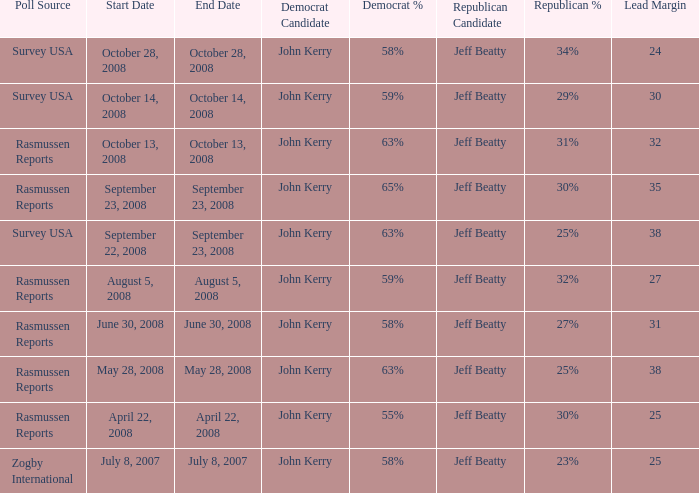Would you be able to parse every entry in this table? {'header': ['Poll Source', 'Start Date', 'End Date', 'Democrat Candidate', 'Democrat %', 'Republican Candidate', 'Republican %', 'Lead Margin'], 'rows': [['Survey USA', 'October 28, 2008', 'October 28, 2008', 'John Kerry', '58%', 'Jeff Beatty', '34%', '24'], ['Survey USA', 'October 14, 2008', 'October 14, 2008', 'John Kerry', '59%', 'Jeff Beatty', '29%', '30'], ['Rasmussen Reports', 'October 13, 2008', 'October 13, 2008', 'John Kerry', '63%', 'Jeff Beatty', '31%', '32'], ['Rasmussen Reports', 'September 23, 2008', 'September 23, 2008', 'John Kerry', '65%', 'Jeff Beatty', '30%', '35'], ['Survey USA', 'September 22, 2008', 'September 23, 2008', 'John Kerry', '63%', 'Jeff Beatty', '25%', '38'], ['Rasmussen Reports', 'August 5, 2008', 'August 5, 2008', 'John Kerry', '59%', 'Jeff Beatty', '32%', '27'], ['Rasmussen Reports', 'June 30, 2008', 'June 30, 2008', 'John Kerry', '58%', 'Jeff Beatty', '27%', '31'], ['Rasmussen Reports', 'May 28, 2008', 'May 28, 2008', 'John Kerry', '63%', 'Jeff Beatty', '25%', '38'], ['Rasmussen Reports', 'April 22, 2008', 'April 22, 2008', 'John Kerry', '55%', 'Jeff Beatty', '30%', '25'], ['Zogby International', 'July 8, 2007', 'July 8, 2007', 'John Kerry', '58%', 'Jeff Beatty', '23%', '25']]} What percent is the lead margin of 25 that Republican: Jeff Beatty has according to poll source Rasmussen Reports? 30%. 